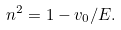Convert formula to latex. <formula><loc_0><loc_0><loc_500><loc_500>n ^ { 2 } = 1 - { v _ { 0 } / E } .</formula> 